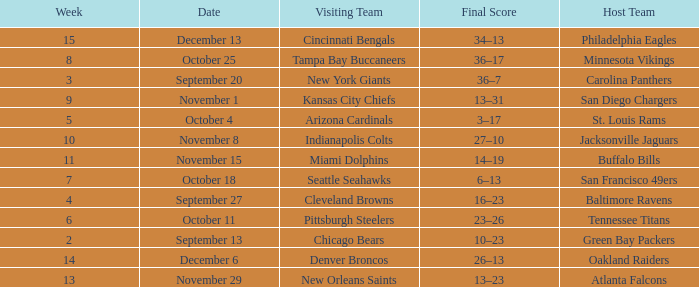What team played on the road against the Buffalo Bills at home ? Miami Dolphins. 